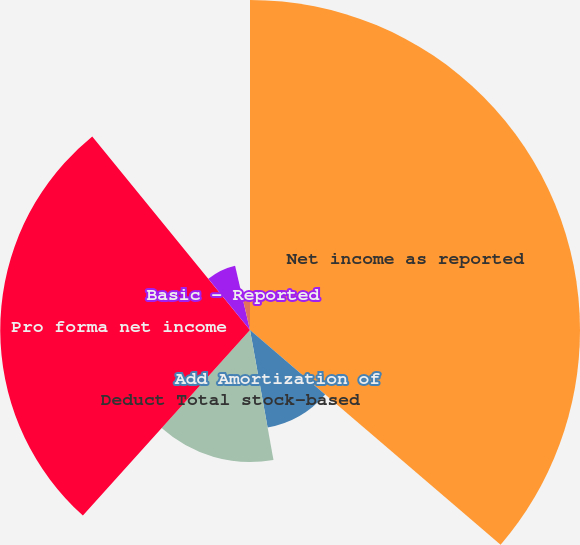Convert chart. <chart><loc_0><loc_0><loc_500><loc_500><pie_chart><fcel>Net income as reported<fcel>Add Amortization of<fcel>Deduct Total stock-based<fcel>Pro forma net income<fcel>Basic - Reported<fcel>Pro forma<fcel>Diluted - Reported<nl><fcel>36.27%<fcel>10.88%<fcel>14.51%<fcel>27.45%<fcel>7.25%<fcel>0.0%<fcel>3.63%<nl></chart> 